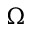<formula> <loc_0><loc_0><loc_500><loc_500>\Omega</formula> 